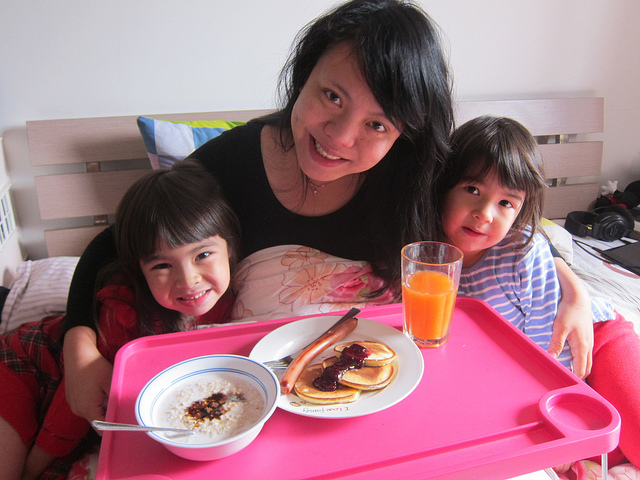How do these people know each other?
A. coworkers
B. family
C. classmates
D. teammates
Answer with the option's letter from the given choices directly. B 